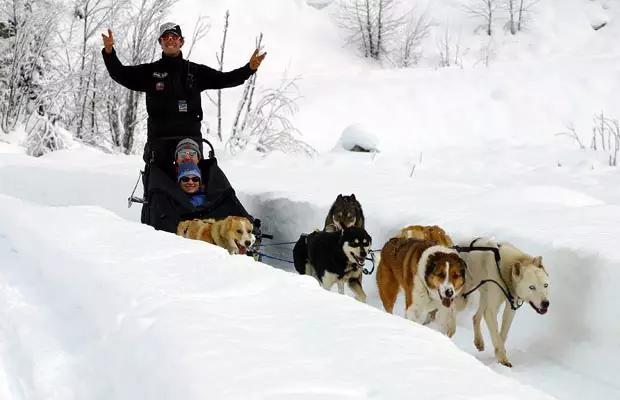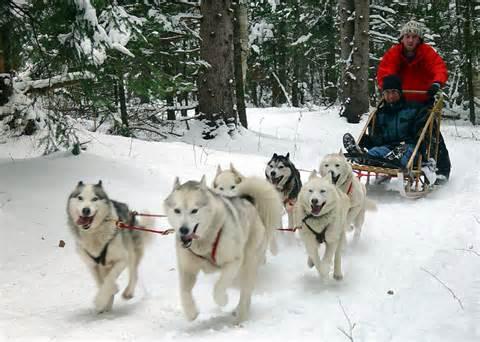The first image is the image on the left, the second image is the image on the right. For the images displayed, is the sentence "In one image, the sled driver wears a bright red jacket." factually correct? Answer yes or no. Yes. The first image is the image on the left, the second image is the image on the right. Evaluate the accuracy of this statement regarding the images: "There is a person in a red coat in the image on the right.". Is it true? Answer yes or no. Yes. 